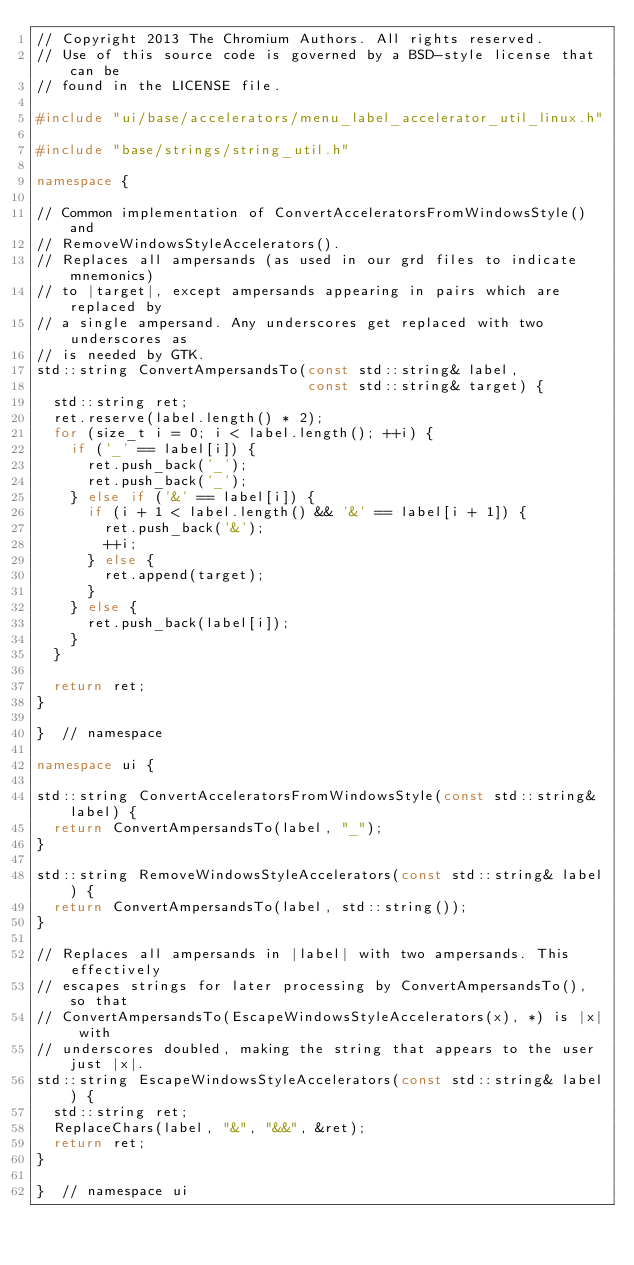Convert code to text. <code><loc_0><loc_0><loc_500><loc_500><_C++_>// Copyright 2013 The Chromium Authors. All rights reserved.
// Use of this source code is governed by a BSD-style license that can be
// found in the LICENSE file.

#include "ui/base/accelerators/menu_label_accelerator_util_linux.h"

#include "base/strings/string_util.h"

namespace {

// Common implementation of ConvertAcceleratorsFromWindowsStyle() and
// RemoveWindowsStyleAccelerators().
// Replaces all ampersands (as used in our grd files to indicate mnemonics)
// to |target|, except ampersands appearing in pairs which are replaced by
// a single ampersand. Any underscores get replaced with two underscores as
// is needed by GTK.
std::string ConvertAmpersandsTo(const std::string& label,
                                const std::string& target) {
  std::string ret;
  ret.reserve(label.length() * 2);
  for (size_t i = 0; i < label.length(); ++i) {
    if ('_' == label[i]) {
      ret.push_back('_');
      ret.push_back('_');
    } else if ('&' == label[i]) {
      if (i + 1 < label.length() && '&' == label[i + 1]) {
        ret.push_back('&');
        ++i;
      } else {
        ret.append(target);
      }
    } else {
      ret.push_back(label[i]);
    }
  }

  return ret;
}

}  // namespace

namespace ui {

std::string ConvertAcceleratorsFromWindowsStyle(const std::string& label) {
  return ConvertAmpersandsTo(label, "_");
}

std::string RemoveWindowsStyleAccelerators(const std::string& label) {
  return ConvertAmpersandsTo(label, std::string());
}

// Replaces all ampersands in |label| with two ampersands. This effectively
// escapes strings for later processing by ConvertAmpersandsTo(), so that
// ConvertAmpersandsTo(EscapeWindowsStyleAccelerators(x), *) is |x| with
// underscores doubled, making the string that appears to the user just |x|.
std::string EscapeWindowsStyleAccelerators(const std::string& label) {
  std::string ret;
  ReplaceChars(label, "&", "&&", &ret);
  return ret;
}

}  // namespace ui
</code> 